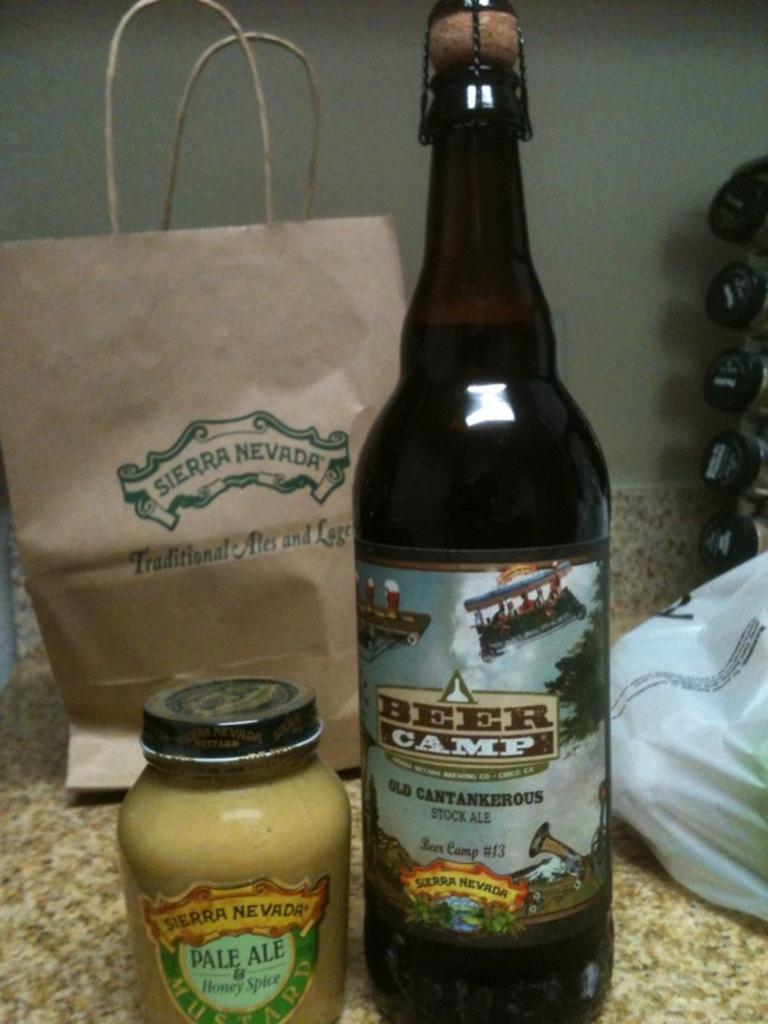<image>
Render a clear and concise summary of the photo. A bottle of Bear Camp is next to the right of a jar of mustard. 